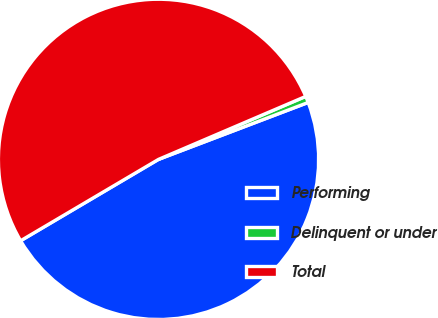<chart> <loc_0><loc_0><loc_500><loc_500><pie_chart><fcel>Performing<fcel>Delinquent or under<fcel>Total<nl><fcel>47.3%<fcel>0.65%<fcel>52.05%<nl></chart> 